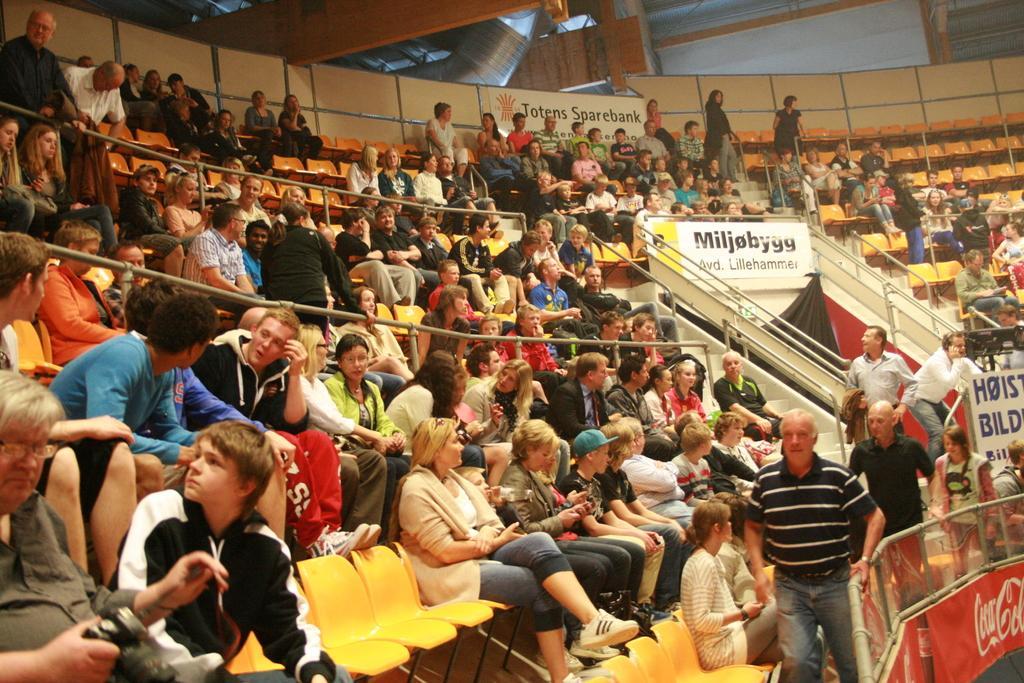Could you give a brief overview of what you see in this image? In this image there are people, chairs, railings, steps, hoardings and objects. Among them few people are standing. Something is written on the hoardings. 